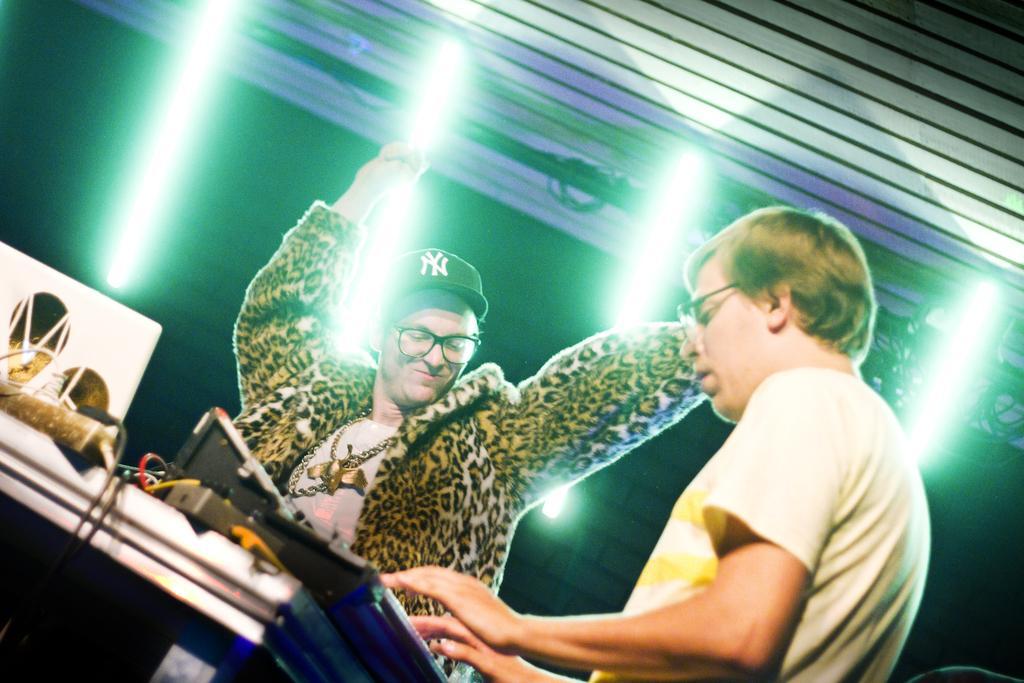Can you describe this image briefly? In the image there are two men playing musical instruments, the man on the right side wearing yellow t-shirt and the man in the middle wearing cheetah jacket with black cap, there are lights over the ceiling. 